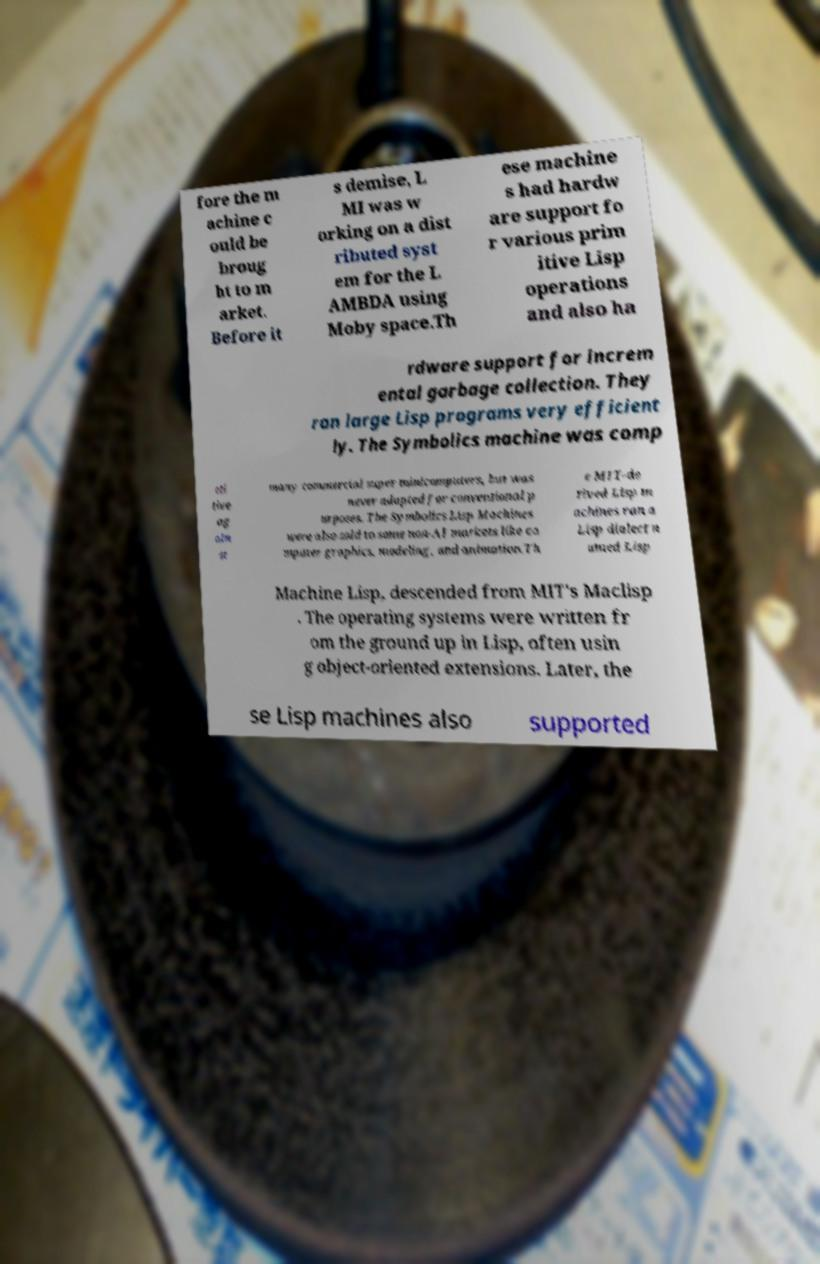I need the written content from this picture converted into text. Can you do that? fore the m achine c ould be broug ht to m arket. Before it s demise, L MI was w orking on a dist ributed syst em for the L AMBDA using Moby space.Th ese machine s had hardw are support fo r various prim itive Lisp operations and also ha rdware support for increm ental garbage collection. They ran large Lisp programs very efficient ly. The Symbolics machine was comp eti tive ag ain st many commercial super minicomputers, but was never adapted for conventional p urposes. The Symbolics Lisp Machines were also sold to some non-AI markets like co mputer graphics, modeling, and animation.Th e MIT-de rived Lisp m achines ran a Lisp dialect n amed Lisp Machine Lisp, descended from MIT's Maclisp . The operating systems were written fr om the ground up in Lisp, often usin g object-oriented extensions. Later, the se Lisp machines also supported 